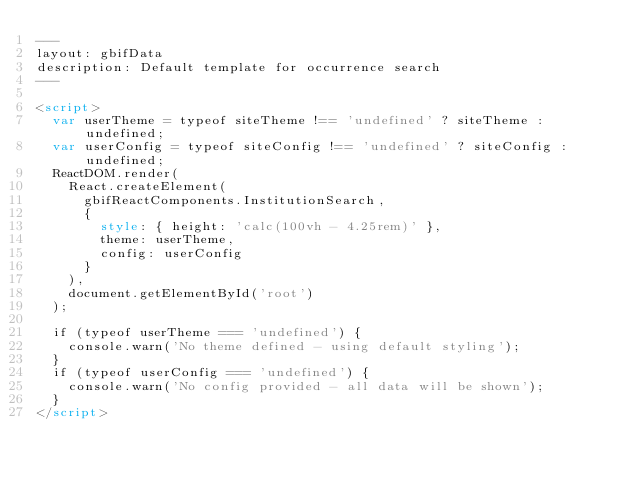Convert code to text. <code><loc_0><loc_0><loc_500><loc_500><_HTML_>---
layout: gbifData
description: Default template for occurrence search
---

<script>
  var userTheme = typeof siteTheme !== 'undefined' ? siteTheme : undefined;
  var userConfig = typeof siteConfig !== 'undefined' ? siteConfig : undefined;
  ReactDOM.render(
    React.createElement(
      gbifReactComponents.InstitutionSearch,
      { 
        style: { height: 'calc(100vh - 4.25rem)' }, 
        theme: userTheme, 
        config: userConfig
      }
    ),
    document.getElementById('root')
  );

  if (typeof userTheme === 'undefined') {
    console.warn('No theme defined - using default styling');
  }
  if (typeof userConfig === 'undefined') {
    console.warn('No config provided - all data will be shown');
  }
</script></code> 